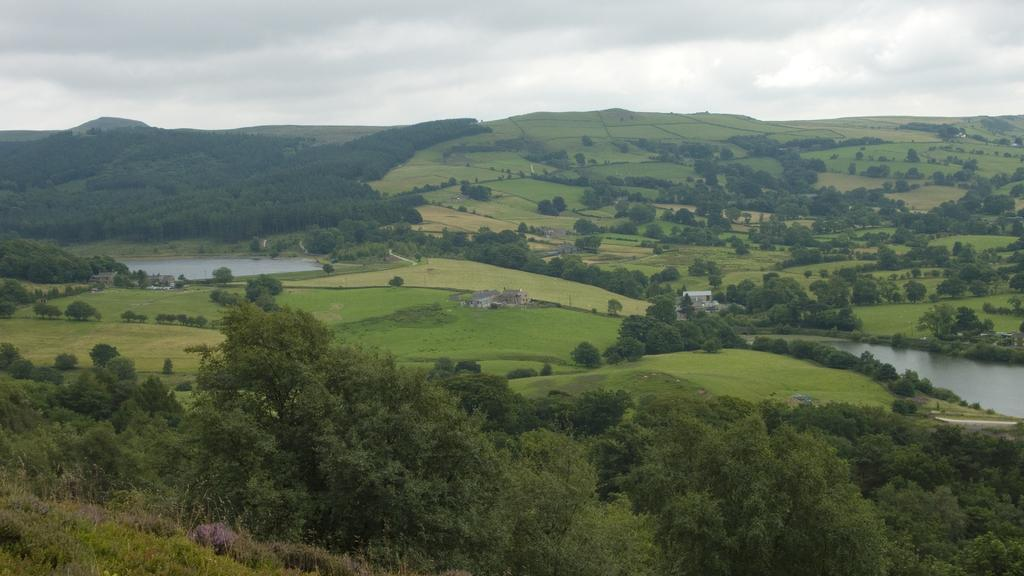What type of vegetation can be seen in the image? There are many trees in the image. What else can be seen besides trees in the image? There is water, buildings, grass on the ground, and the sky visible in the image. Can you describe the ground in the image? The ground in the image is covered with grass. What is visible in the background of the image? The sky is visible in the background of the image, and there are clouds in the sky. What type of hammer can be seen in the image? There is no hammer present in the image. Can you describe the dog in the image? There is no dog present in the image. 